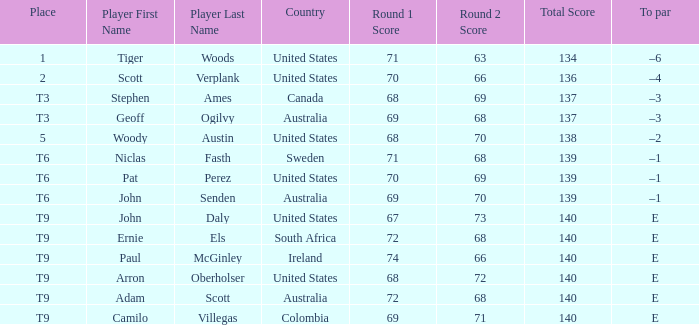Can you parse all the data within this table? {'header': ['Place', 'Player First Name', 'Player Last Name', 'Country', 'Round 1 Score', 'Round 2 Score', 'Total Score', 'To par'], 'rows': [['1', 'Tiger', 'Woods', 'United States', '71', '63', '134', '–6'], ['2', 'Scott', 'Verplank', 'United States', '70', '66', '136', '–4'], ['T3', 'Stephen', 'Ames', 'Canada', '68', '69', '137', '–3'], ['T3', 'Geoff', 'Ogilvy', 'Australia', '69', '68', '137', '–3'], ['5', 'Woody', 'Austin', 'United States', '68', '70', '138', '–2'], ['T6', 'Niclas', 'Fasth', 'Sweden', '71', '68', '139', '–1'], ['T6', 'Pat', 'Perez', 'United States', '70', '69', '139', '–1'], ['T6', 'John', 'Senden', 'Australia', '69', '70', '139', '–1'], ['T9', 'John', 'Daly', 'United States', '67', '73', '140', 'E'], ['T9', 'Ernie', 'Els', 'South Africa', '72', '68', '140', 'E'], ['T9', 'Paul', 'McGinley', 'Ireland', '74', '66', '140', 'E'], ['T9', 'Arron', 'Oberholser', 'United States', '68', '72', '140', 'E'], ['T9', 'Adam', 'Scott', 'Australia', '72', '68', '140', 'E'], ['T9', 'Camilo', 'Villegas', 'Colombia', '69', '71', '140', 'E']]} Which player is from Sweden? Niclas Fasth. 